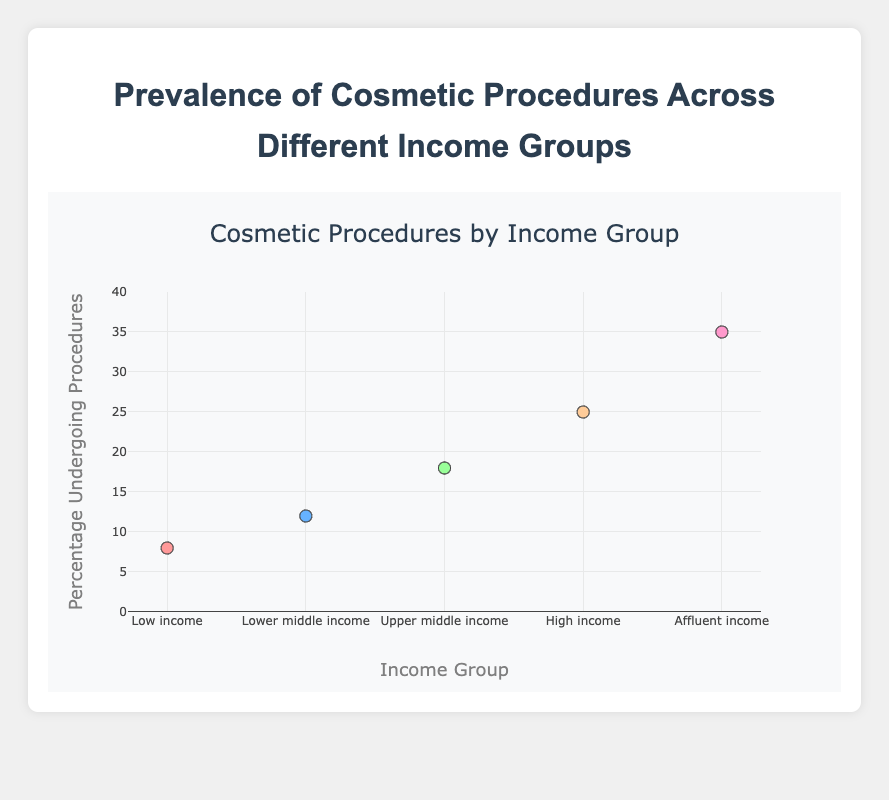What is the title of the scatter plot? The title is clearly indicated at the top of the plot.
Answer: Prevalence of Cosmetic Procedures Across Different Income Groups How many distinct income groups are represented in the scatter plot? Each data point corresponds to an income group. By counting these points, one can see that there are 5 distinct groups.
Answer: 5 What is the percentage of people undergoing cosmetic procedures in the "Upper middle income" group? The y-axis indicates the percentage, and by referencing the "Upper middle income" group on the x-axis, we find the corresponding y value.
Answer: 18% Which income group has the highest percentage of people undergoing cosmetic procedures? By comparing all the y-values, the highest percentage can be identified, which is associated with the "Affluent income" group.
Answer: Affluent income How much greater is the percentage of people undergoing procedures in the "Affluent income" group compared to the "Low income" group? Subtract the percentage of the "Low income" group from the "Affluent income" group: 35% - 8% = 27%.
Answer: 27% What is the average percentage of people undergoing procedures across all five income groups? Sum the percentages and divide by the number of groups: (8% + 12% + 18% + 25% + 35%) / 5 = 19.6%.
Answer: 19.6% Which income group shows a middle value (median) in terms of the percentage undergoing procedures? Organize the percentages in ascending order: 8%, 12%, 18%, 25%, 35%. The middle value is at the 3rd position, which corresponds to the "Upper middle income" group.
Answer: Upper middle income Are there any income groups where the percentage of people undergoing procedures is less than 10%? By examining the y-values, only the "Low income" group has a percentage of 8%, which is less than 10%.
Answer: Low income What is the general trend observed in the scatter plot as income increases? The trend shows a positive correlation between increasing income levels and higher percentages of people undergoing cosmetic procedures.
Answer: Positive correlation How does the percentage of cosmetic procedures in the "High income" group compare to that in the "Lower middle income" group? By looking at the y-values, the "High income" group has 25% and the "Lower middle income" group has 12%. 25% is greater than 12%.
Answer: Greater 